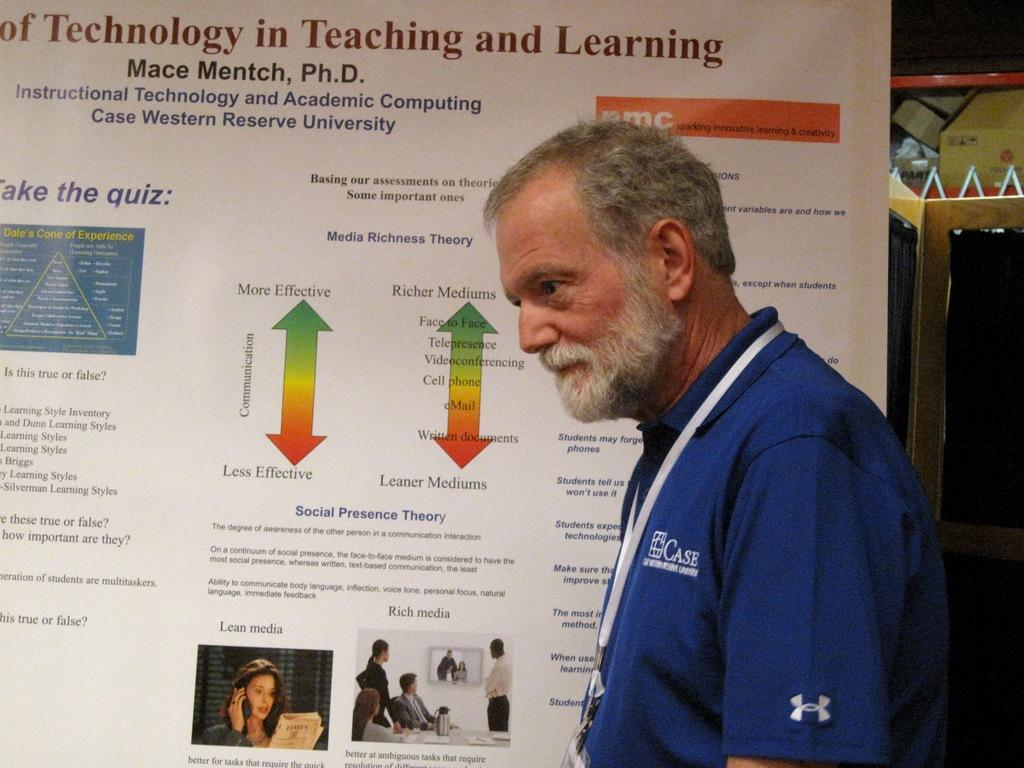<image>
Give a short and clear explanation of the subsequent image. An older gentleman from Case Western Reserve University stands in front of an informative notice board. 